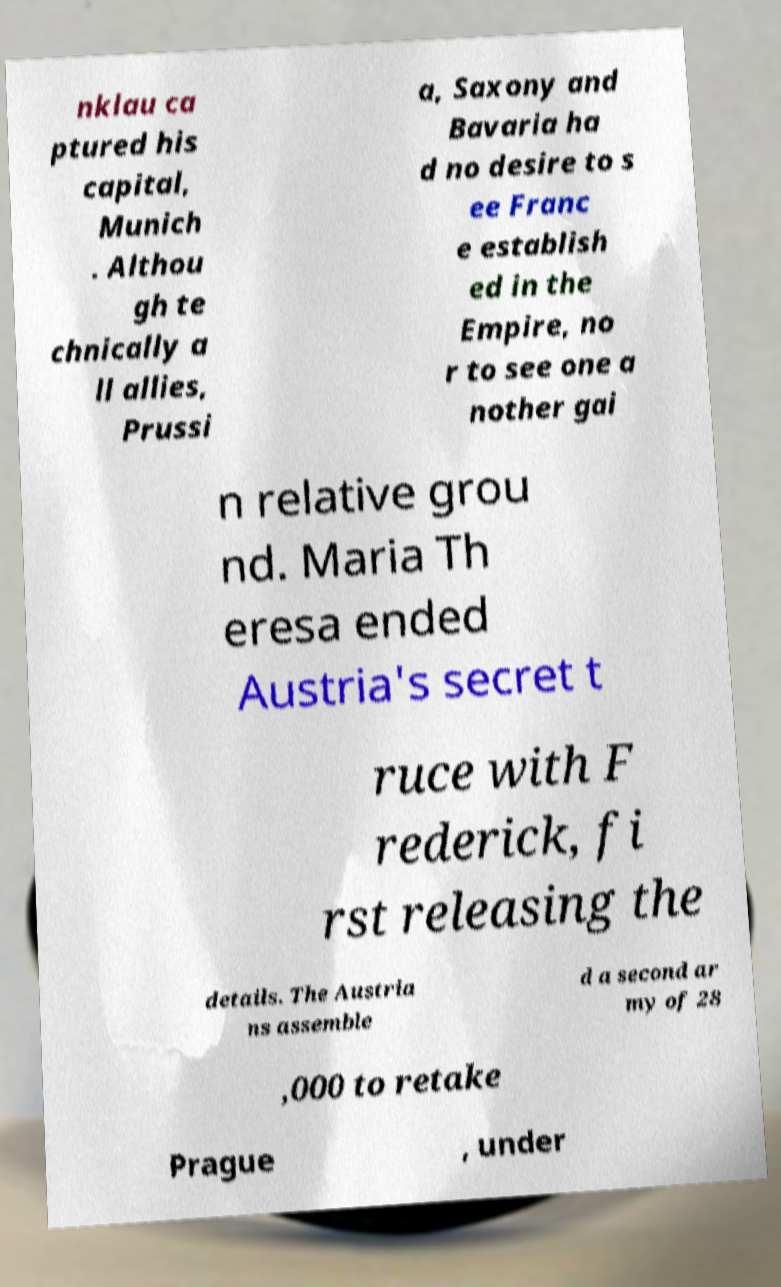Can you accurately transcribe the text from the provided image for me? nklau ca ptured his capital, Munich . Althou gh te chnically a ll allies, Prussi a, Saxony and Bavaria ha d no desire to s ee Franc e establish ed in the Empire, no r to see one a nother gai n relative grou nd. Maria Th eresa ended Austria's secret t ruce with F rederick, fi rst releasing the details. The Austria ns assemble d a second ar my of 28 ,000 to retake Prague , under 